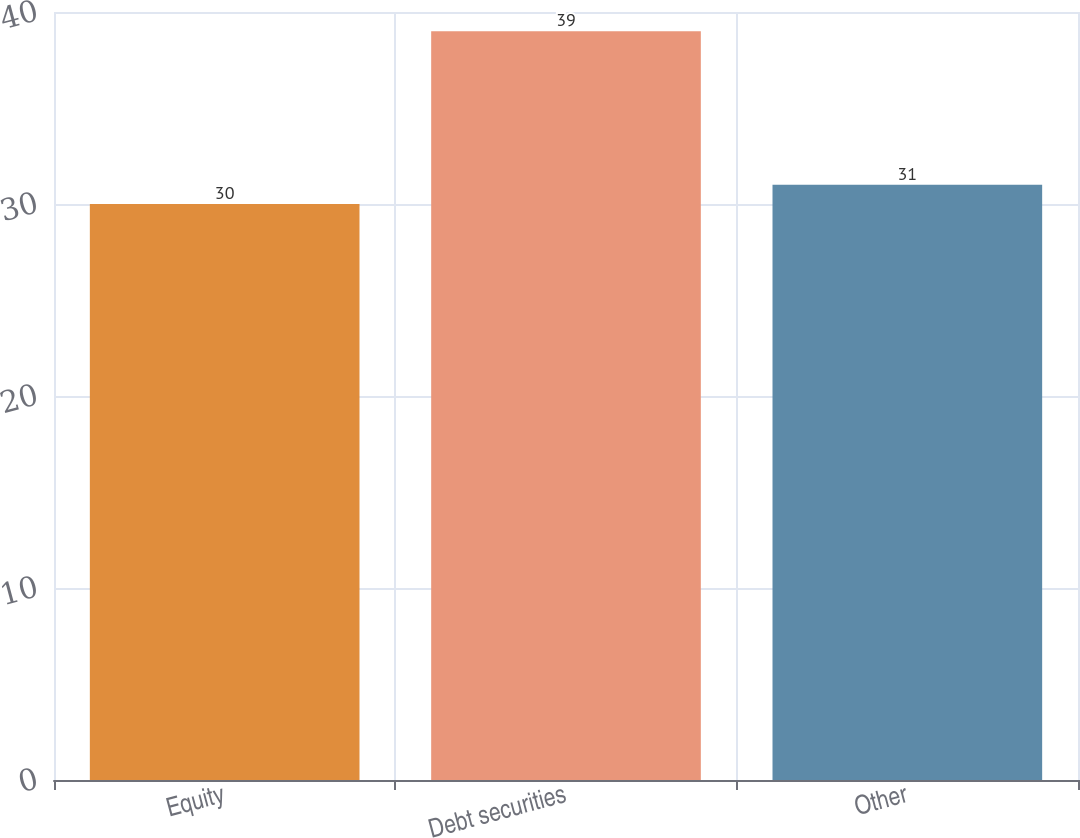<chart> <loc_0><loc_0><loc_500><loc_500><bar_chart><fcel>Equity<fcel>Debt securities<fcel>Other<nl><fcel>30<fcel>39<fcel>31<nl></chart> 